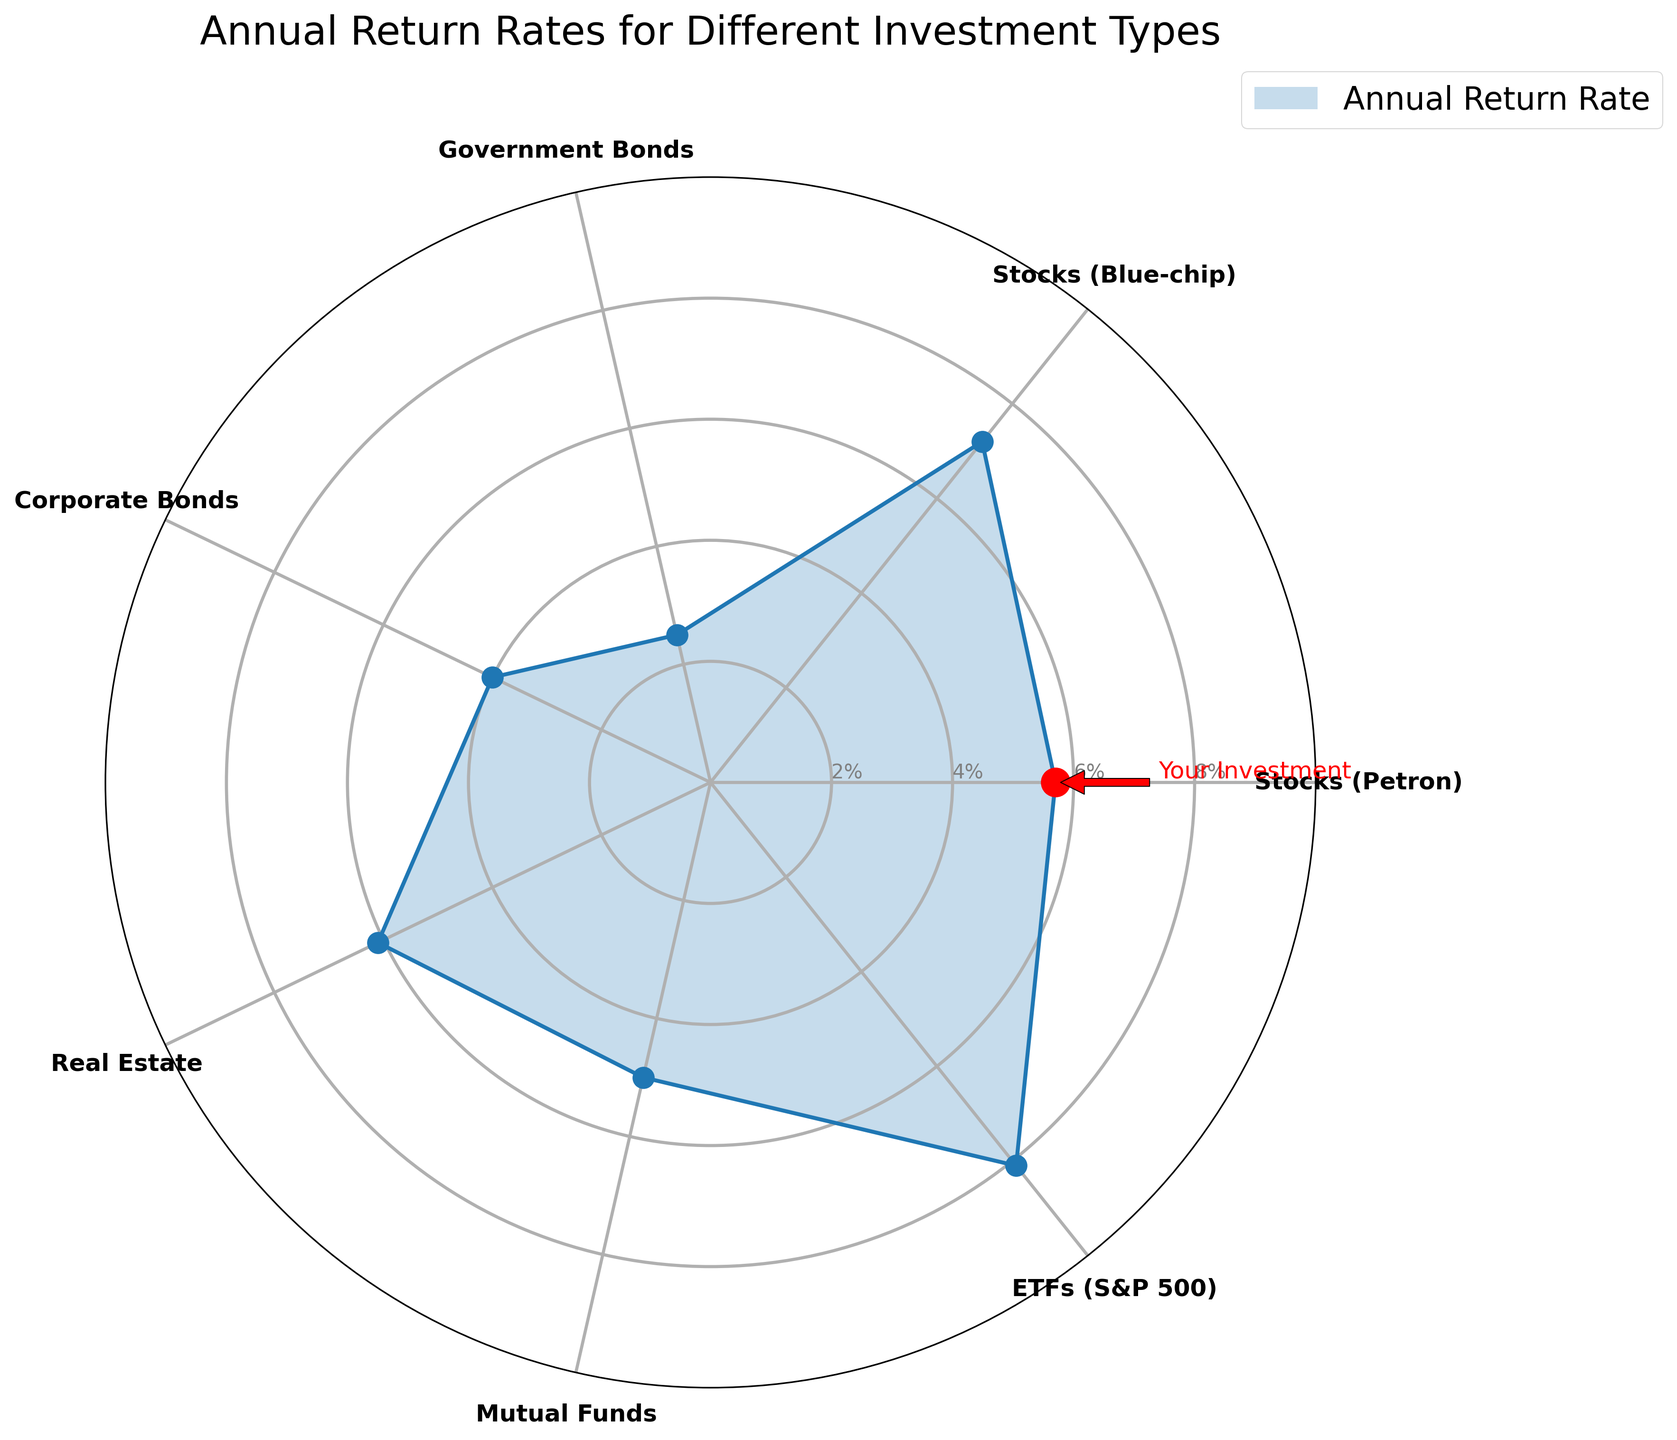What is the title of the chart? The title is the text at the top of the chart which summarizes the content of the figure.
Answer: Annual Return Rates for Different Investment Types How many different investment types are represented in the chart? Count the number of distinct labels around the polar area chart.
Answer: 7 Which investment type has the highest annual return rate? Locate the label with the point furthest from the center.
Answer: ETFs (S&P 500) What is the annual return rate for Stocks (Petron)? Find the label for Stocks (Petron) and read the value on the radial axis intersecting that label.
Answer: 5.7% How does the return rate of Stocks (Petron) compare to Government Bonds? Compare the radial distance of Stocks (Petron) and Government Bonds from the center.
Answer: Stocks (Petron) has a higher return rate than Government Bonds List the investment types with annual return rates higher than Real Estate. Identify all labels farther from the center than Real Estate, which has a rate of 6.1%.
Answer: Blue-chip Stocks, ETFs (S&P 500) What is the difference in annual return rates between ETFs (S&P 500) and Government Bonds? Subtract the return rate of Government Bonds (2.5%) from that of ETFs (S&P 500) (8.1%).
Answer: 5.6% What is the average annual return rate of all the investment types? Sum all the return rates and divide by the number of investment types: (5.7 + 7.2 + 2.5 + 4.0 + 6.1 + 5.0 + 8.1)/7.
Answer: 5.51% What visual element highlights Stocks (Petron) in the figure? Look for any unique marker or annotation on the chart.
Answer: A large red dot and annotation with an arrow What are the median and the range of the annual return rates? Sort the return rates and find the middle value (median), and subtract the smallest value from the largest value for the range. The sorted values are 2.5, 4.0, 5.0, 5.7, 6.1, 7.2, 8.1. Median is the middle one (5.7), range is (8.1 - 2.5).
Answer: Median: 5.7%, Range: 5.6% 